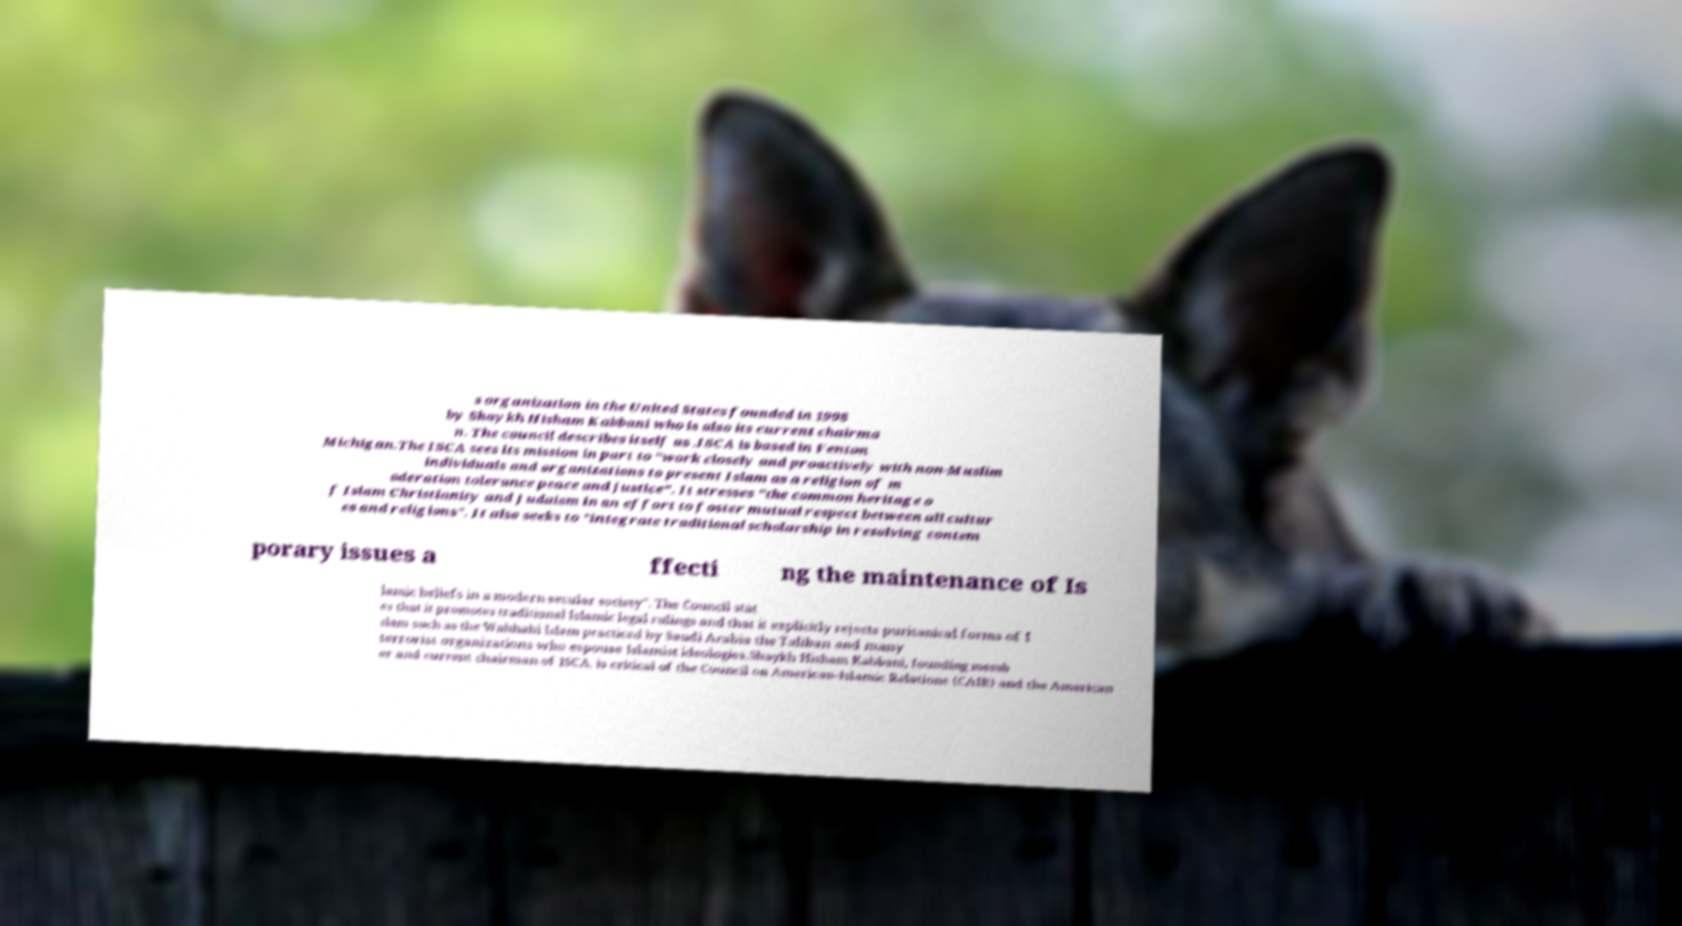Could you extract and type out the text from this image? s organization in the United States founded in 1998 by Shaykh Hisham Kabbani who is also its current chairma n. The council describes itself as .ISCA is based in Fenton Michigan.The ISCA sees its mission in part to "work closely and proactively with non-Muslim individuals and organizations to present Islam as a religion of m oderation tolerance peace and justice". It stresses "the common heritage o f Islam Christianity and Judaism in an effort to foster mutual respect between all cultur es and religions". It also seeks to "integrate traditional scholarship in resolving contem porary issues a ffecti ng the maintenance of Is lamic beliefs in a modern secular society". The Council stat es that it promotes traditional Islamic legal rulings and that it explicitly rejects puritanical forms of I slam such as the Wahhabi Islam practiced by Saudi Arabia the Taliban and many terrorist organizations who espouse Islamist ideologies.Shaykh Hisham Kabbani, founding memb er and current chairman of ISCA, is critical of the Council on American-Islamic Relations (CAIR) and the American 